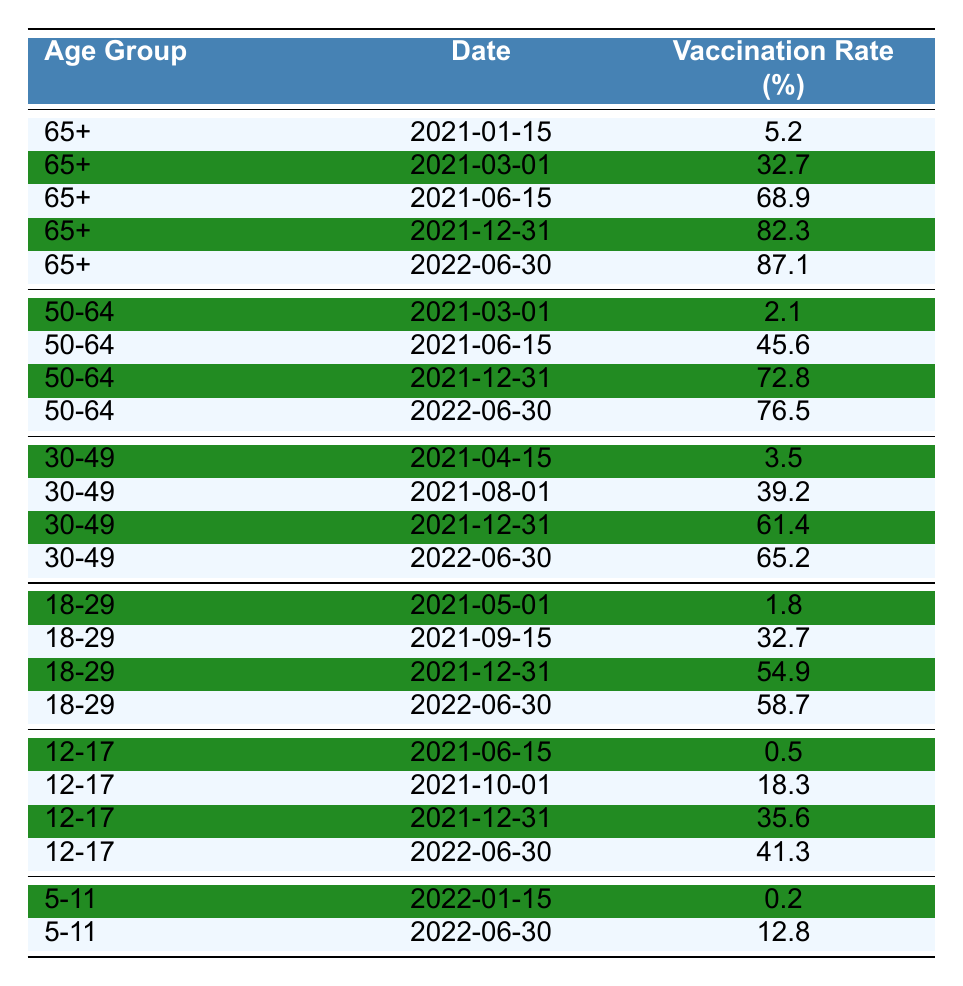What was the vaccination rate for the age group 65+ on December 31, 2021? Looking at the data for the age group 65+, the entry for December 31, 2021, shows a vaccination rate of 82.3%.
Answer: 82.3% What is the difference in vaccination rates between the age groups 50-64 and 65+ on June 30, 2022? The vaccination rate for 50-64 on June 30, 2022, is 76.5% and for 65+ is 87.1%. The difference is 87.1 - 76.5 = 10.6%.
Answer: 10.6% Is the vaccination rate for the age group 12-17 higher than that for 5-11 on June 30, 2022? The table shows that the vaccination rate for 12-17 is 41.3% and for 5-11 is 12.8%. Since 41.3 is greater than 12.8, the statement is true.
Answer: Yes What was the average vaccination rate for the age group 30-49 over all recorded dates? The rates for age group 30-49 are 3.5%, 39.2%, 61.4%, and 65.2%. Adding these values gives 169.3%, and dividing by the number of entries (4) results in an average of 42.325%.
Answer: 42.3% How much did the vaccination rate for the age group 18-29 increase between May 1, 2021, and December 31, 2021? The vaccination rate on May 1, 2021, was 1.8% and on December 31, 2021, it was 54.9%. The increase is calculated as 54.9 - 1.8 = 53.1%.
Answer: 53.1% Which age group had the lowest vaccination rate on January 15, 2022? On January 15, 2022, the only group recorded was 5-11, with a vaccination rate of 0.2%. No other groups are listed for this date, so 5-11 has the lowest rate.
Answer: 5-11 What is the trend in vaccination rates for the age group 50-64 from March 1, 2021, to June 30, 2022? The rates for 50-64 were 2.1% on March 1, 2021, increasing to 76.5% by June 30, 2022. This shows a consistent upward trend.
Answer: Upward trend When did the vaccination rate for the age group 12-17 first exceed 20%? The vaccination rate for 12-17 first exceeds 20% at 18.3% on October 1, 2021, which is still below 20%, but becomes 35.6% on December 31, 2021. So, the first date it exceeded 20% was December 31, 2021.
Answer: December 31, 2021 What age group had the highest vaccination rate recorded throughout the data? The highest vaccination rate recorded is for the age group 65+ at 87.1% on June 30, 2022.
Answer: 65+ What percentage of the age group 5-11 was vaccinated by June 30, 2022? The vaccination rate for the age group 5-11 by June 30, 2022, is recorded as 12.8%.
Answer: 12.8% 